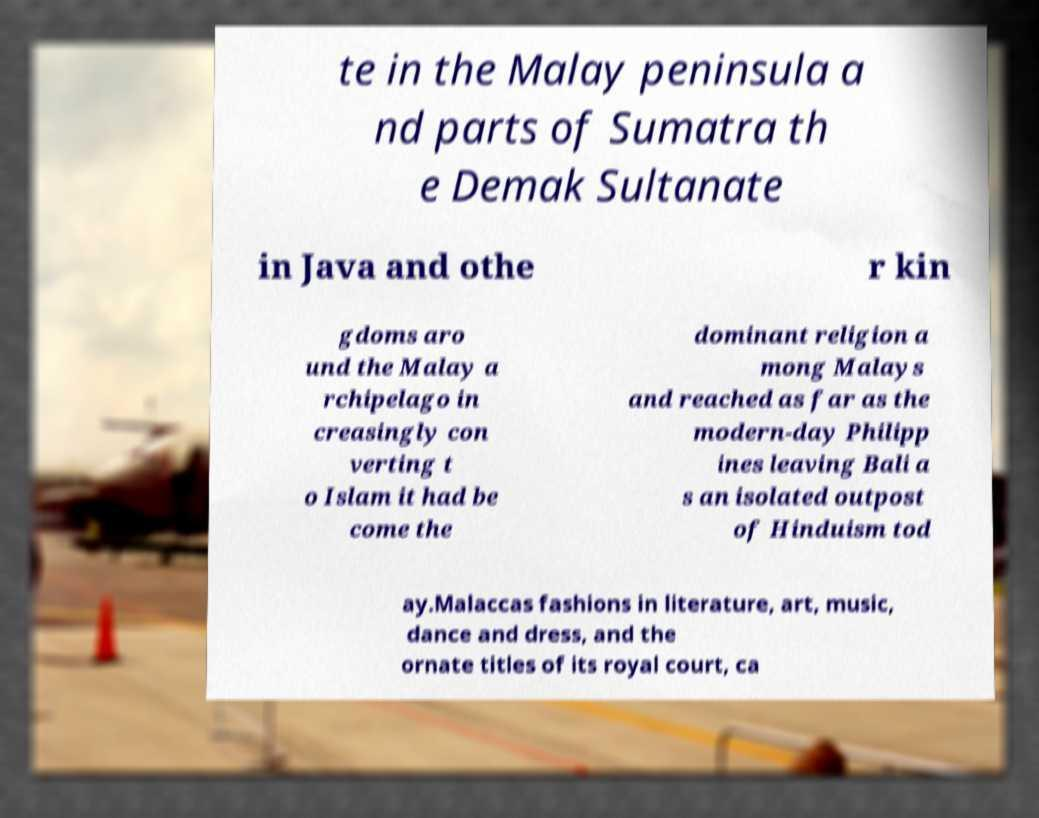Could you assist in decoding the text presented in this image and type it out clearly? te in the Malay peninsula a nd parts of Sumatra th e Demak Sultanate in Java and othe r kin gdoms aro und the Malay a rchipelago in creasingly con verting t o Islam it had be come the dominant religion a mong Malays and reached as far as the modern-day Philipp ines leaving Bali a s an isolated outpost of Hinduism tod ay.Malaccas fashions in literature, art, music, dance and dress, and the ornate titles of its royal court, ca 